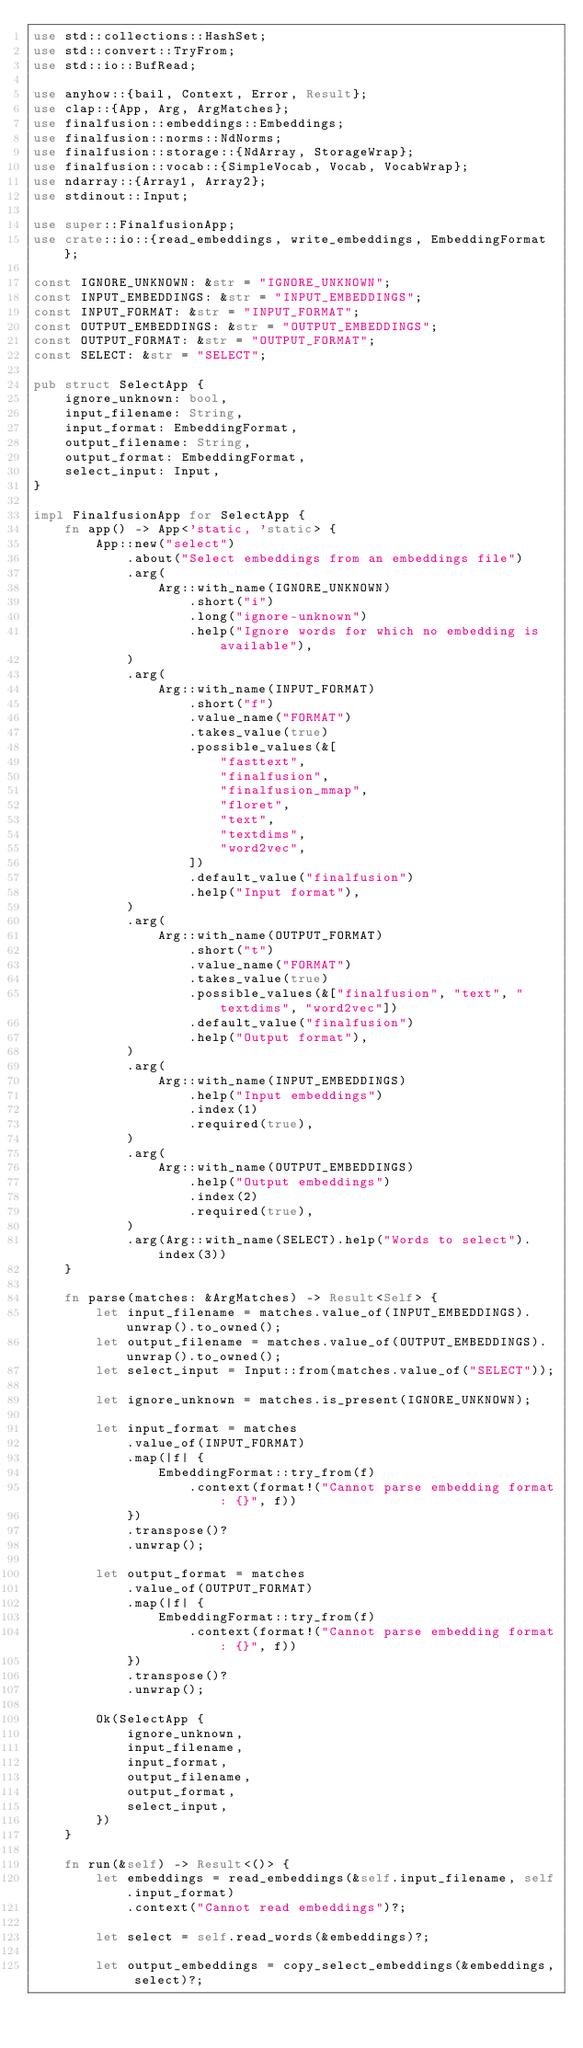Convert code to text. <code><loc_0><loc_0><loc_500><loc_500><_Rust_>use std::collections::HashSet;
use std::convert::TryFrom;
use std::io::BufRead;

use anyhow::{bail, Context, Error, Result};
use clap::{App, Arg, ArgMatches};
use finalfusion::embeddings::Embeddings;
use finalfusion::norms::NdNorms;
use finalfusion::storage::{NdArray, StorageWrap};
use finalfusion::vocab::{SimpleVocab, Vocab, VocabWrap};
use ndarray::{Array1, Array2};
use stdinout::Input;

use super::FinalfusionApp;
use crate::io::{read_embeddings, write_embeddings, EmbeddingFormat};

const IGNORE_UNKNOWN: &str = "IGNORE_UNKNOWN";
const INPUT_EMBEDDINGS: &str = "INPUT_EMBEDDINGS";
const INPUT_FORMAT: &str = "INPUT_FORMAT";
const OUTPUT_EMBEDDINGS: &str = "OUTPUT_EMBEDDINGS";
const OUTPUT_FORMAT: &str = "OUTPUT_FORMAT";
const SELECT: &str = "SELECT";

pub struct SelectApp {
    ignore_unknown: bool,
    input_filename: String,
    input_format: EmbeddingFormat,
    output_filename: String,
    output_format: EmbeddingFormat,
    select_input: Input,
}

impl FinalfusionApp for SelectApp {
    fn app() -> App<'static, 'static> {
        App::new("select")
            .about("Select embeddings from an embeddings file")
            .arg(
                Arg::with_name(IGNORE_UNKNOWN)
                    .short("i")
                    .long("ignore-unknown")
                    .help("Ignore words for which no embedding is available"),
            )
            .arg(
                Arg::with_name(INPUT_FORMAT)
                    .short("f")
                    .value_name("FORMAT")
                    .takes_value(true)
                    .possible_values(&[
                        "fasttext",
                        "finalfusion",
                        "finalfusion_mmap",
                        "floret",
                        "text",
                        "textdims",
                        "word2vec",
                    ])
                    .default_value("finalfusion")
                    .help("Input format"),
            )
            .arg(
                Arg::with_name(OUTPUT_FORMAT)
                    .short("t")
                    .value_name("FORMAT")
                    .takes_value(true)
                    .possible_values(&["finalfusion", "text", "textdims", "word2vec"])
                    .default_value("finalfusion")
                    .help("Output format"),
            )
            .arg(
                Arg::with_name(INPUT_EMBEDDINGS)
                    .help("Input embeddings")
                    .index(1)
                    .required(true),
            )
            .arg(
                Arg::with_name(OUTPUT_EMBEDDINGS)
                    .help("Output embeddings")
                    .index(2)
                    .required(true),
            )
            .arg(Arg::with_name(SELECT).help("Words to select").index(3))
    }

    fn parse(matches: &ArgMatches) -> Result<Self> {
        let input_filename = matches.value_of(INPUT_EMBEDDINGS).unwrap().to_owned();
        let output_filename = matches.value_of(OUTPUT_EMBEDDINGS).unwrap().to_owned();
        let select_input = Input::from(matches.value_of("SELECT"));

        let ignore_unknown = matches.is_present(IGNORE_UNKNOWN);

        let input_format = matches
            .value_of(INPUT_FORMAT)
            .map(|f| {
                EmbeddingFormat::try_from(f)
                    .context(format!("Cannot parse embedding format: {}", f))
            })
            .transpose()?
            .unwrap();

        let output_format = matches
            .value_of(OUTPUT_FORMAT)
            .map(|f| {
                EmbeddingFormat::try_from(f)
                    .context(format!("Cannot parse embedding format: {}", f))
            })
            .transpose()?
            .unwrap();

        Ok(SelectApp {
            ignore_unknown,
            input_filename,
            input_format,
            output_filename,
            output_format,
            select_input,
        })
    }

    fn run(&self) -> Result<()> {
        let embeddings = read_embeddings(&self.input_filename, self.input_format)
            .context("Cannot read embeddings")?;

        let select = self.read_words(&embeddings)?;

        let output_embeddings = copy_select_embeddings(&embeddings, select)?;
</code> 